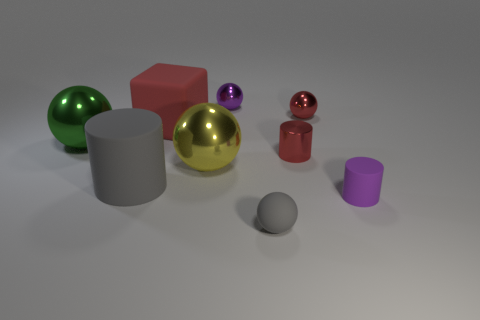Subtract all gray spheres. How many spheres are left? 4 Subtract all gray spheres. How many spheres are left? 4 Add 1 small gray shiny cylinders. How many objects exist? 10 Subtract all cylinders. How many objects are left? 6 Subtract 1 purple balls. How many objects are left? 8 Subtract 2 balls. How many balls are left? 3 Subtract all purple cylinders. Subtract all blue spheres. How many cylinders are left? 2 Subtract all red balls. How many gray cubes are left? 0 Subtract all big metallic objects. Subtract all small gray matte spheres. How many objects are left? 6 Add 8 small metallic cylinders. How many small metallic cylinders are left? 9 